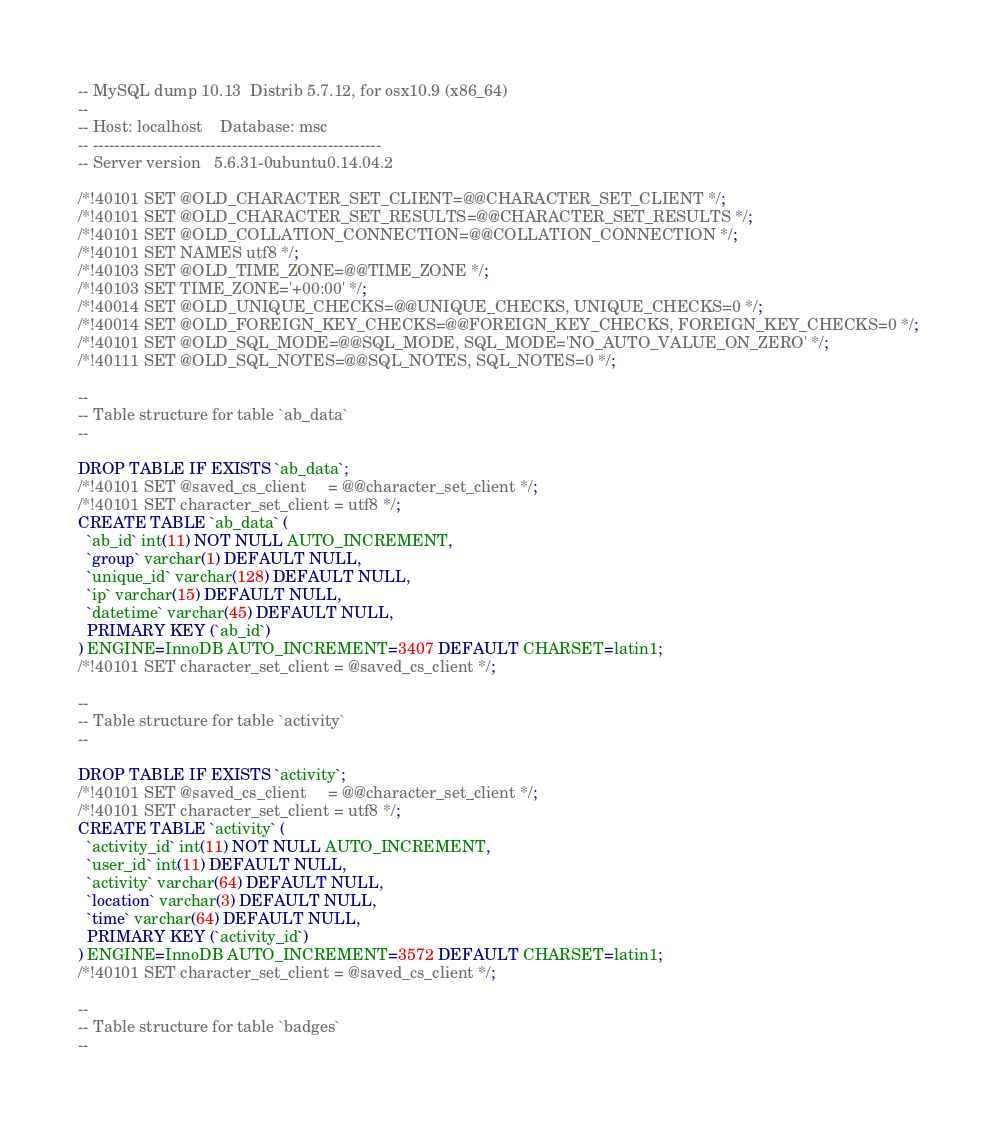Convert code to text. <code><loc_0><loc_0><loc_500><loc_500><_SQL_>-- MySQL dump 10.13  Distrib 5.7.12, for osx10.9 (x86_64)
--
-- Host: localhost    Database: msc
-- ------------------------------------------------------
-- Server version	5.6.31-0ubuntu0.14.04.2

/*!40101 SET @OLD_CHARACTER_SET_CLIENT=@@CHARACTER_SET_CLIENT */;
/*!40101 SET @OLD_CHARACTER_SET_RESULTS=@@CHARACTER_SET_RESULTS */;
/*!40101 SET @OLD_COLLATION_CONNECTION=@@COLLATION_CONNECTION */;
/*!40101 SET NAMES utf8 */;
/*!40103 SET @OLD_TIME_ZONE=@@TIME_ZONE */;
/*!40103 SET TIME_ZONE='+00:00' */;
/*!40014 SET @OLD_UNIQUE_CHECKS=@@UNIQUE_CHECKS, UNIQUE_CHECKS=0 */;
/*!40014 SET @OLD_FOREIGN_KEY_CHECKS=@@FOREIGN_KEY_CHECKS, FOREIGN_KEY_CHECKS=0 */;
/*!40101 SET @OLD_SQL_MODE=@@SQL_MODE, SQL_MODE='NO_AUTO_VALUE_ON_ZERO' */;
/*!40111 SET @OLD_SQL_NOTES=@@SQL_NOTES, SQL_NOTES=0 */;

--
-- Table structure for table `ab_data`
--

DROP TABLE IF EXISTS `ab_data`;
/*!40101 SET @saved_cs_client     = @@character_set_client */;
/*!40101 SET character_set_client = utf8 */;
CREATE TABLE `ab_data` (
  `ab_id` int(11) NOT NULL AUTO_INCREMENT,
  `group` varchar(1) DEFAULT NULL,
  `unique_id` varchar(128) DEFAULT NULL,
  `ip` varchar(15) DEFAULT NULL,
  `datetime` varchar(45) DEFAULT NULL,
  PRIMARY KEY (`ab_id`)
) ENGINE=InnoDB AUTO_INCREMENT=3407 DEFAULT CHARSET=latin1;
/*!40101 SET character_set_client = @saved_cs_client */;

--
-- Table structure for table `activity`
--

DROP TABLE IF EXISTS `activity`;
/*!40101 SET @saved_cs_client     = @@character_set_client */;
/*!40101 SET character_set_client = utf8 */;
CREATE TABLE `activity` (
  `activity_id` int(11) NOT NULL AUTO_INCREMENT,
  `user_id` int(11) DEFAULT NULL,
  `activity` varchar(64) DEFAULT NULL,
  `location` varchar(3) DEFAULT NULL,
  `time` varchar(64) DEFAULT NULL,
  PRIMARY KEY (`activity_id`)
) ENGINE=InnoDB AUTO_INCREMENT=3572 DEFAULT CHARSET=latin1;
/*!40101 SET character_set_client = @saved_cs_client */;

--
-- Table structure for table `badges`
--
</code> 